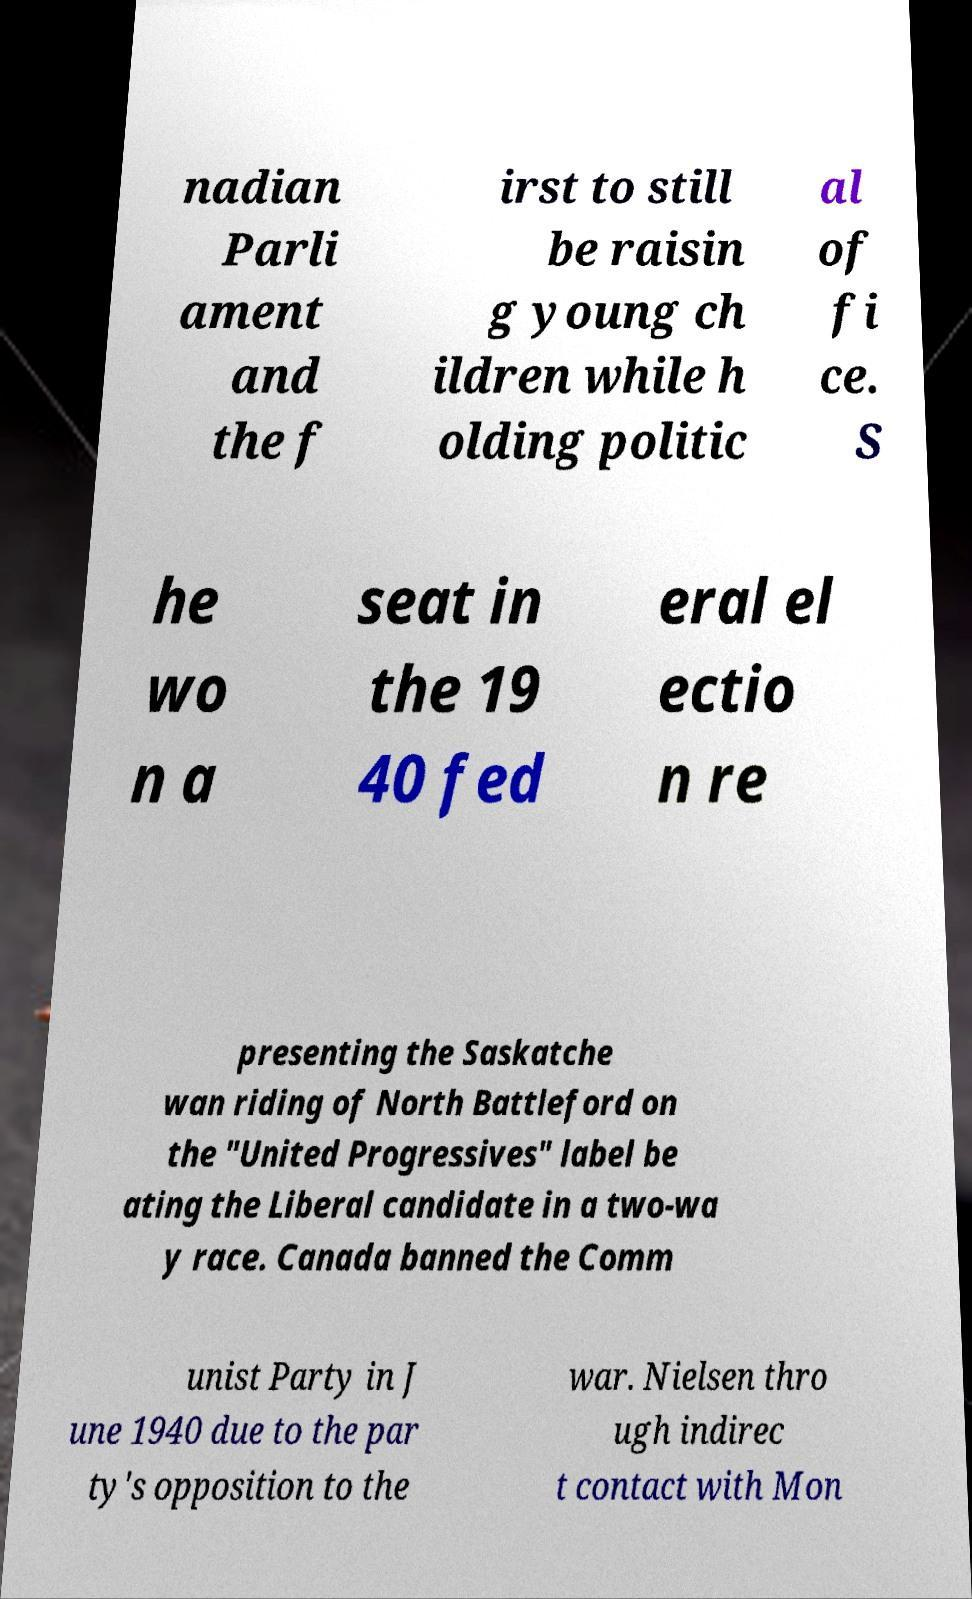Please read and relay the text visible in this image. What does it say? nadian Parli ament and the f irst to still be raisin g young ch ildren while h olding politic al of fi ce. S he wo n a seat in the 19 40 fed eral el ectio n re presenting the Saskatche wan riding of North Battleford on the "United Progressives" label be ating the Liberal candidate in a two-wa y race. Canada banned the Comm unist Party in J une 1940 due to the par ty's opposition to the war. Nielsen thro ugh indirec t contact with Mon 